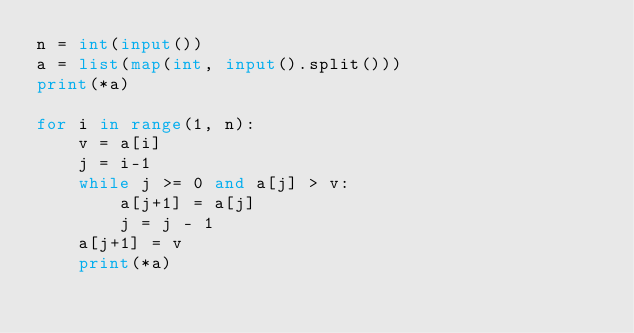Convert code to text. <code><loc_0><loc_0><loc_500><loc_500><_Python_>n = int(input())
a = list(map(int, input().split()))
print(*a)

for i in range(1, n):
    v = a[i]
    j = i-1
    while j >= 0 and a[j] > v:
        a[j+1] = a[j]
        j = j - 1
    a[j+1] = v
    print(*a)
</code> 